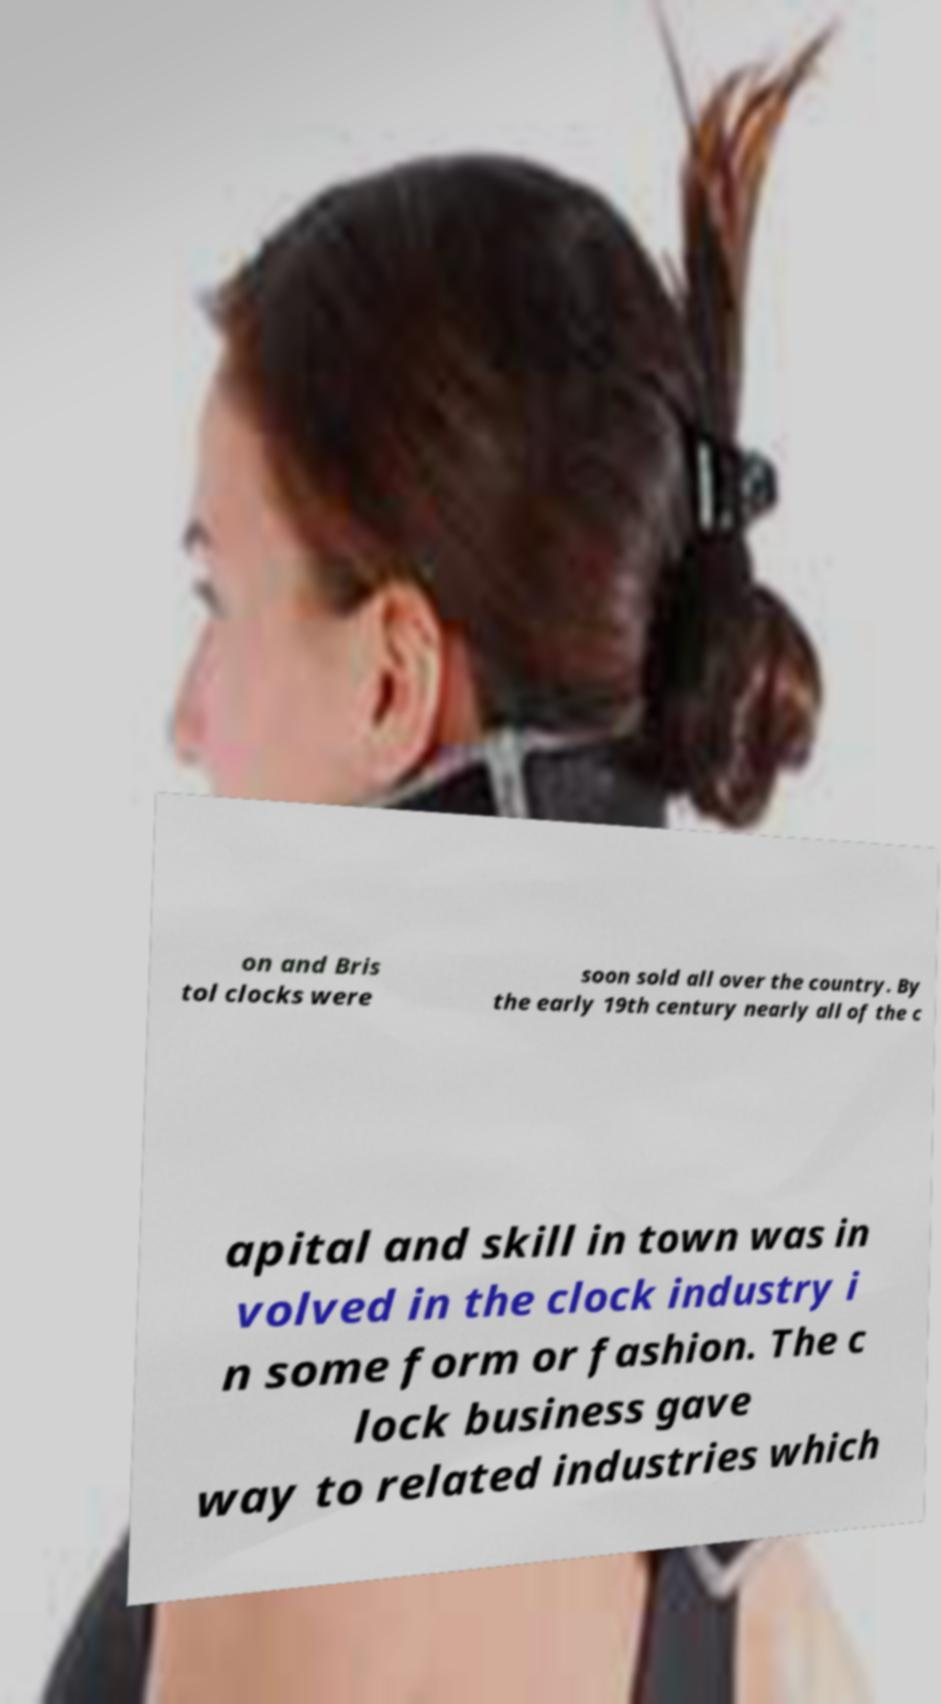What messages or text are displayed in this image? I need them in a readable, typed format. on and Bris tol clocks were soon sold all over the country. By the early 19th century nearly all of the c apital and skill in town was in volved in the clock industry i n some form or fashion. The c lock business gave way to related industries which 